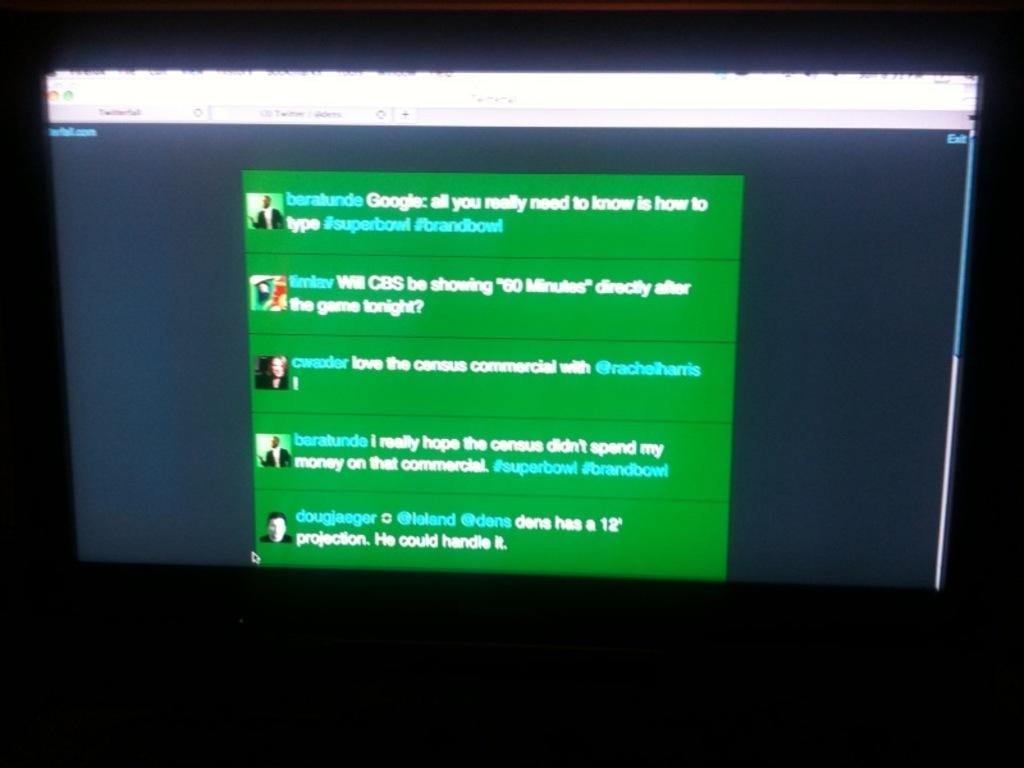What comment is at the very top?
Your response must be concise. All you really need to know is how to type. What are the hashtag words on the top conversation bubble?
Your answer should be compact. #superbowl #brandbowl. 